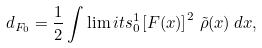<formula> <loc_0><loc_0><loc_500><loc_500>d _ { F _ { 0 } } = \frac { 1 } { 2 } \int \lim i t s ^ { 1 } _ { 0 } \left [ F ( x ) \right ] ^ { 2 } \, \tilde { \rho } ( x ) \, d x ,</formula> 